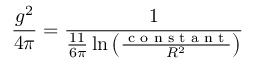<formula> <loc_0><loc_0><loc_500><loc_500>\frac { g ^ { 2 } } { 4 \pi } = \frac { 1 } { \frac { 1 1 } { 6 \pi } \ln \left ( \frac { c o n s t a n t } { R ^ { 2 } } \right ) }</formula> 